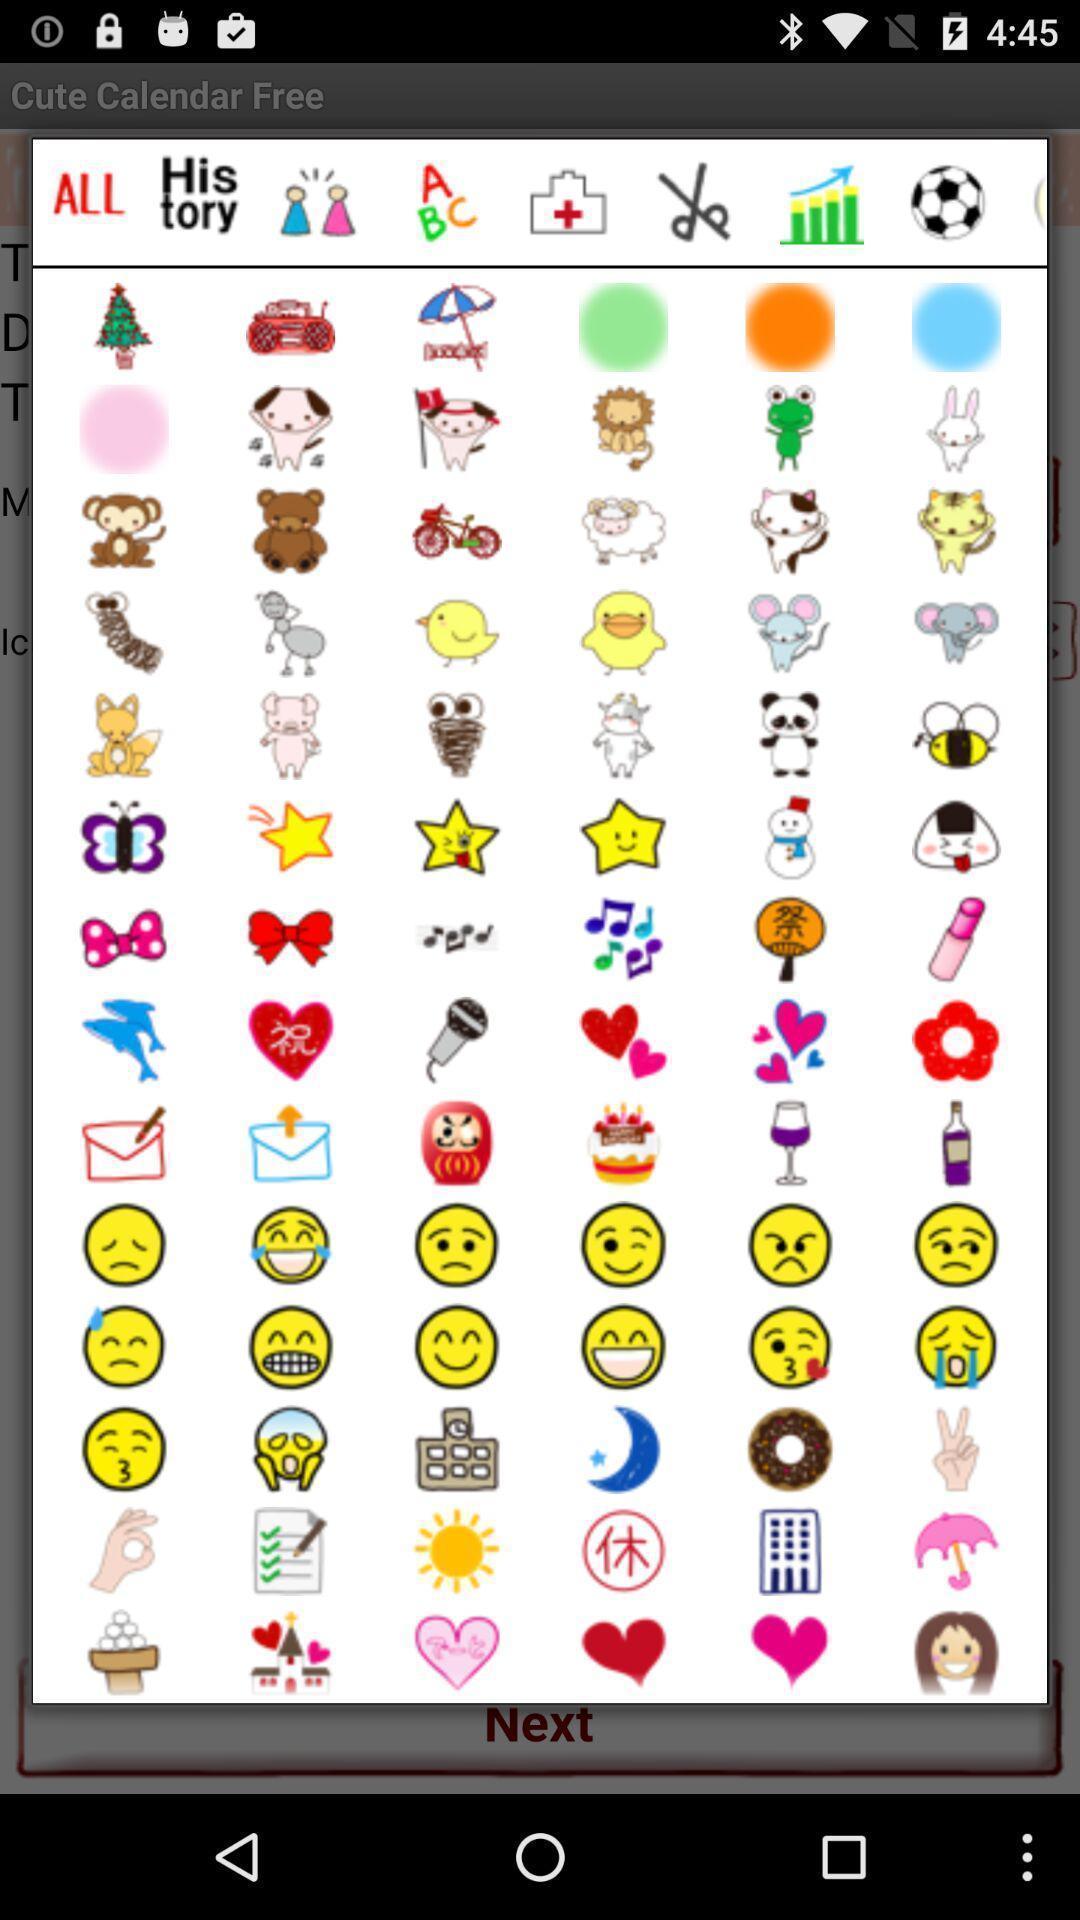What details can you identify in this image? Pop-up shows different stickers. 